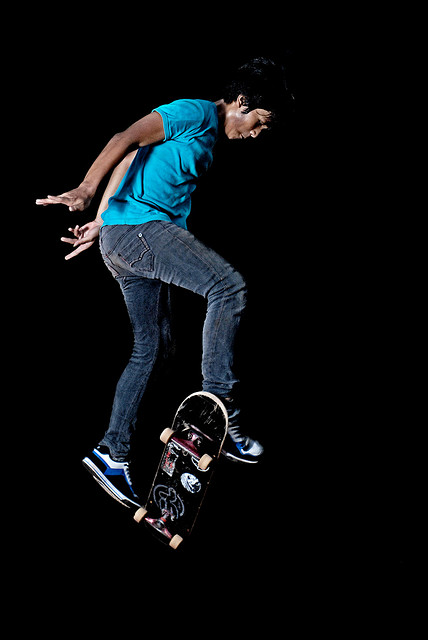<image>What is the word on the snowboard? I am not sure. There are no words on the snowboard. What is the word on the snowboard? I am not sure what is the word on the snowboard. It can be seen 'peace', 'none', 'that is skateboard', 'i am not sure', 'no word on skateboard', or 'no words'. 